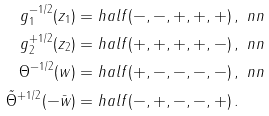Convert formula to latex. <formula><loc_0><loc_0><loc_500><loc_500>g _ { 1 } ^ { - 1 / 2 } ( z _ { 1 } ) = & \ h a l f ( - , - , + , + , + ) \, , \ n n \\ g _ { 2 } ^ { + 1 / 2 } ( z _ { 2 } ) = & \ h a l f ( + , + , + , + , - ) \, , \ n n \\ \Theta ^ { - 1 / 2 } ( w ) = & \ h a l f ( + , - , - , - , - ) \, , \ n n \\ \tilde { \Theta } ^ { + 1 / 2 } ( - \bar { w } ) = & \ h a l f ( - , + , - , - , + ) \, .</formula> 